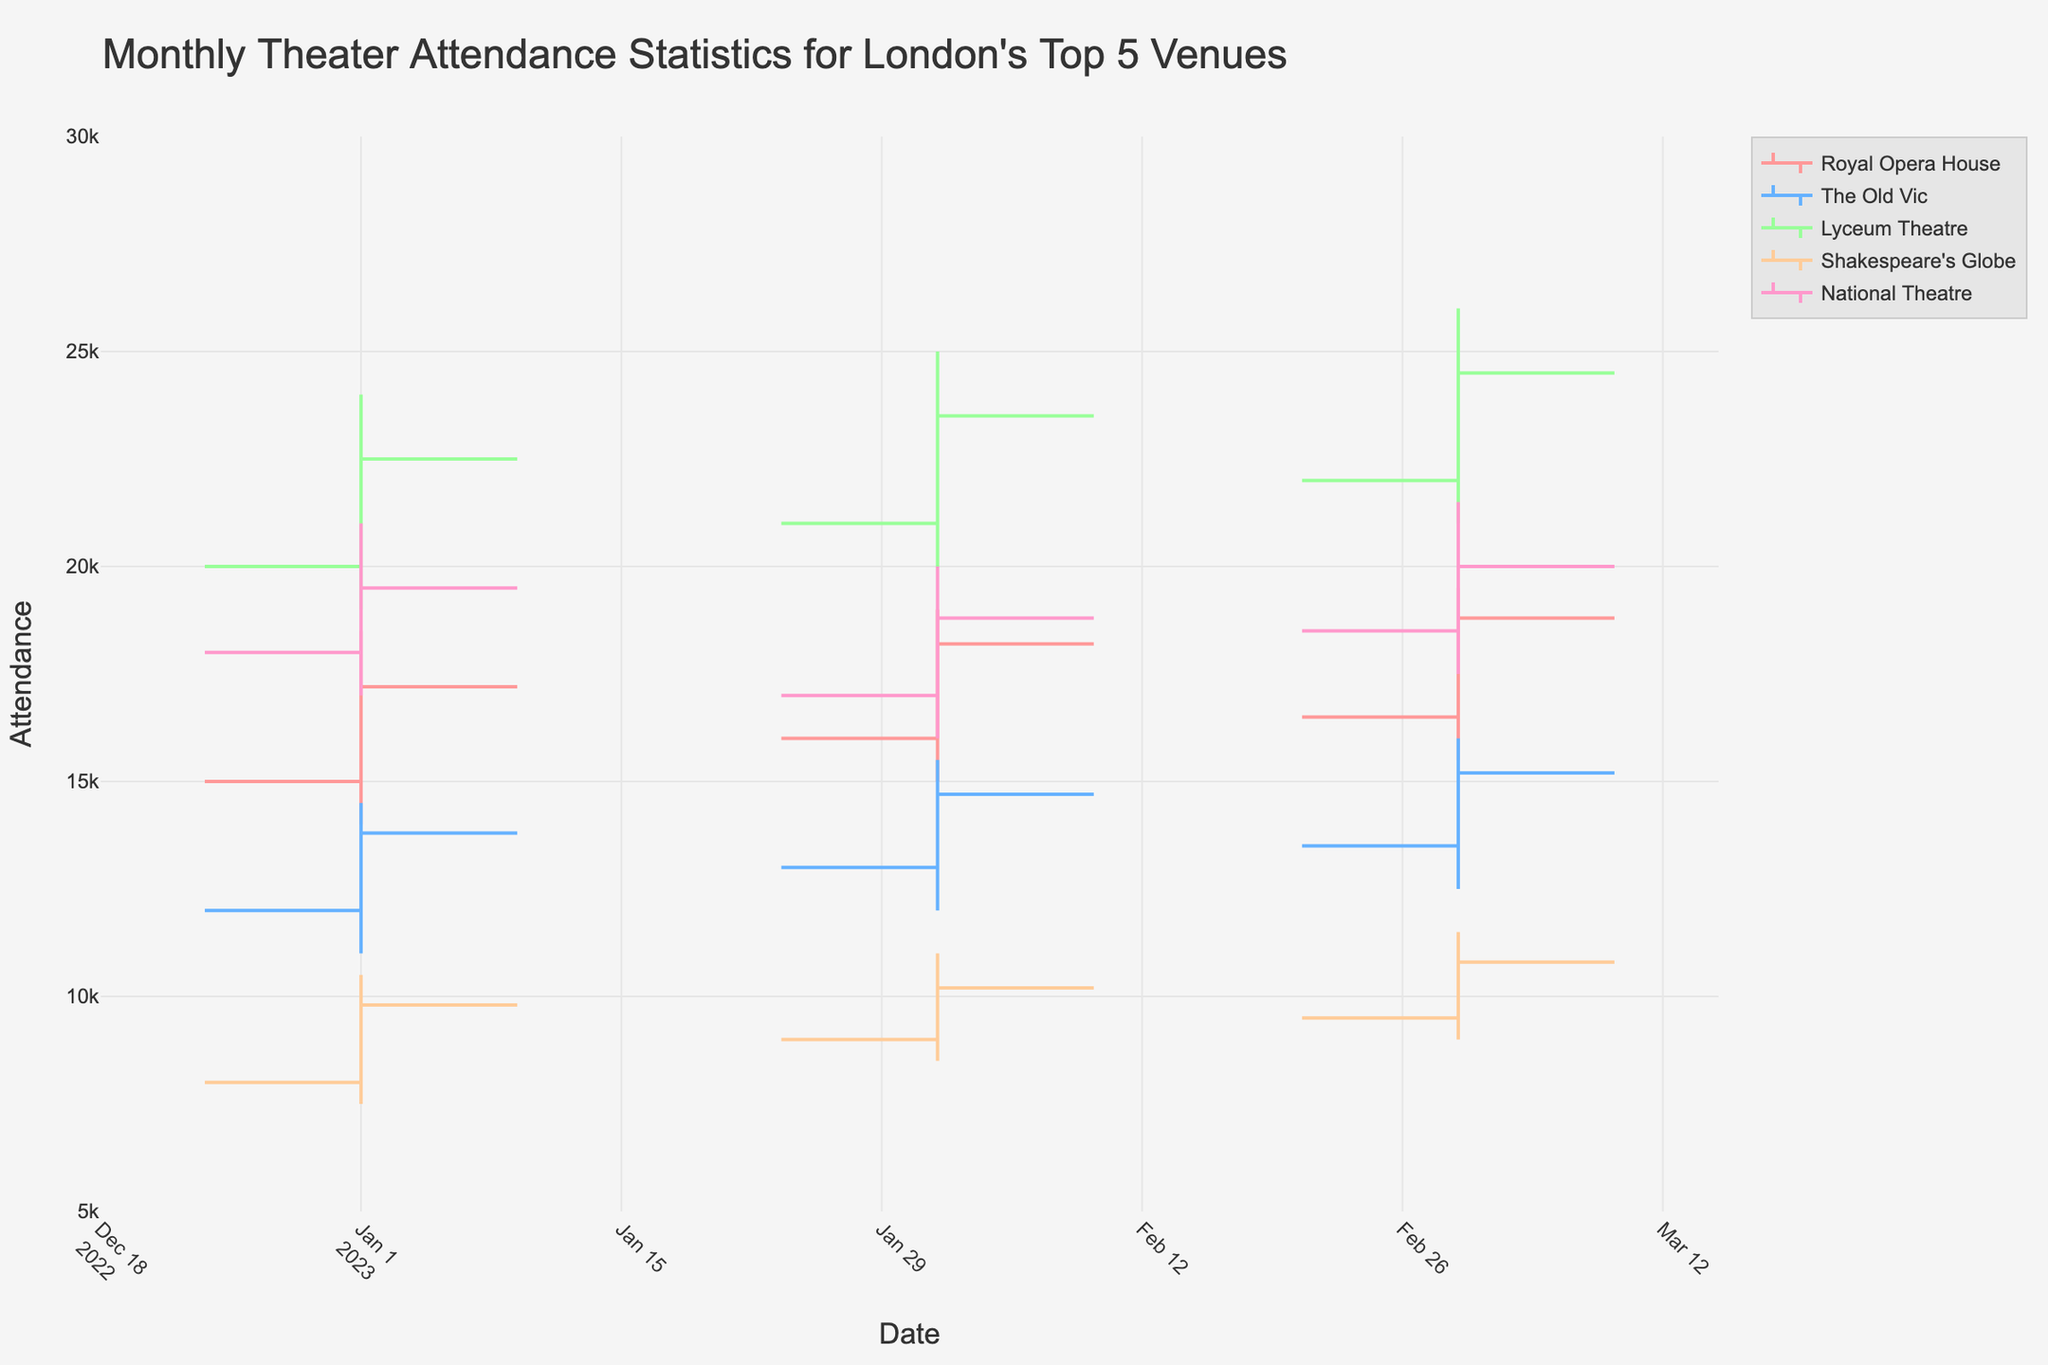What's the title of the figure? The title can be found at the top of the figure in a larger and bold font. It reads "Monthly Theater Attendance Statistics for London's Top 5 Venues".
Answer: Monthly Theater Attendance Statistics for London's Top 5 Venues Which venue has the highest opening attendance in January 2023? By looking at the OHLC bars for January 2023, the highest opening attendance value is highlighted for the Lyceum Theatre. Its Open value is 20,000.
Answer: Lyceum Theatre How does the attendance trend for Royal Opera House between January and March 2023? Observing the OHLC bars for the Royal Opera House over these months, one can see that the attendance generally increases. Open in January is 15,000, which increases to 16,500 by March, and the Close in January is 17,200, which rises to 18,800 by March.
Answer: Increasing Which genre has the lowest closing attendance in February 2023? Looking at the closing prices for all genres in February 2023, the Historical genre at Shakespeare's Globe has the lowest closing attendance of 10,200.
Answer: Historical Compare the attendance trends between the Lyceum Theatre and the National Theatre in January 2023. Which has a more stable attendance range? The attendance range for Lyceum Theatre for January 2023 is from 19,000 to 24,000, while for National Theatre it ranges from 17,000 to 21,000. The National Theatre has a narrower range, indicating a more stable attendance.
Answer: National Theatre What is the total range of attendances for Shakespeare's Globe in March 2023? The range is represented by the highest and lowest points in the OHLC chart. For Shakespeare's Globe in March 2023, it is from 9,000 to 11,500. This gives a range of 11,500 - 9,000 = 2,500.
Answer: 2,500 Which venue had the highest peak attendance in February 2023? The highest attendance peak in February 2023 is represented by the High values of the OHLC bars. The Lyceum Theatre hit the highest peak with a High value of 25,000.
Answer: Lyceum Theatre Looking at the attendance data for March 2023, which venue has the closest difference between its high and low values? Evaluating each OHLC bar's High and Low values in March 2023, for The Old Vic, the difference between the high (16,000) and low (12,500) is 3,500, which is the smallest among all venues.
Answer: The Old Vic What's the average closing attendance for the Royal Opera House from January to March 2023? Add the close values for these months (17,200 + 18,200 + 18,800 = 54,200), then divide by 3. The average is 54,200/3 = 18,067.
Answer: 18,067 